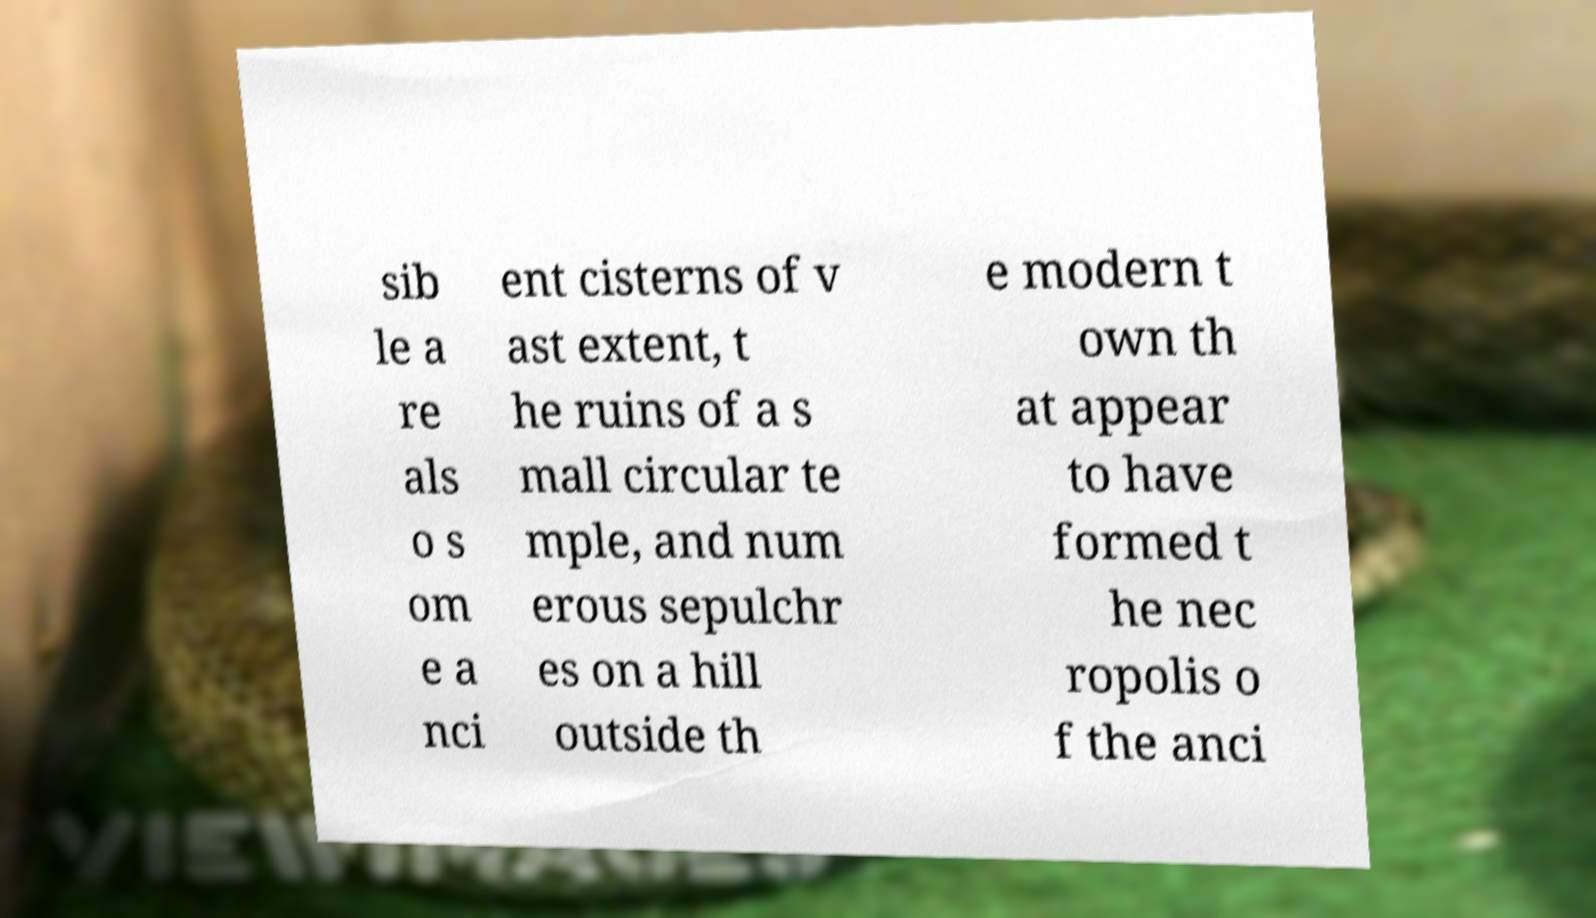Please identify and transcribe the text found in this image. sib le a re als o s om e a nci ent cisterns of v ast extent, t he ruins of a s mall circular te mple, and num erous sepulchr es on a hill outside th e modern t own th at appear to have formed t he nec ropolis o f the anci 